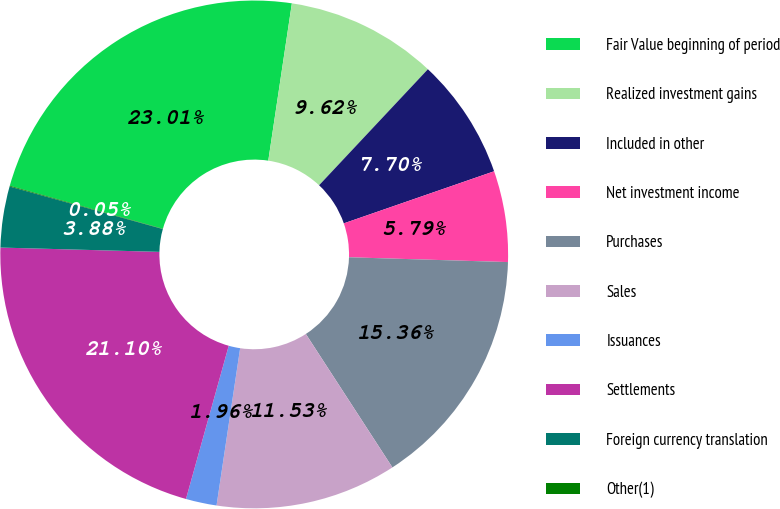<chart> <loc_0><loc_0><loc_500><loc_500><pie_chart><fcel>Fair Value beginning of period<fcel>Realized investment gains<fcel>Included in other<fcel>Net investment income<fcel>Purchases<fcel>Sales<fcel>Issuances<fcel>Settlements<fcel>Foreign currency translation<fcel>Other(1)<nl><fcel>23.01%<fcel>9.62%<fcel>7.7%<fcel>5.79%<fcel>15.36%<fcel>11.53%<fcel>1.96%<fcel>21.1%<fcel>3.88%<fcel>0.05%<nl></chart> 